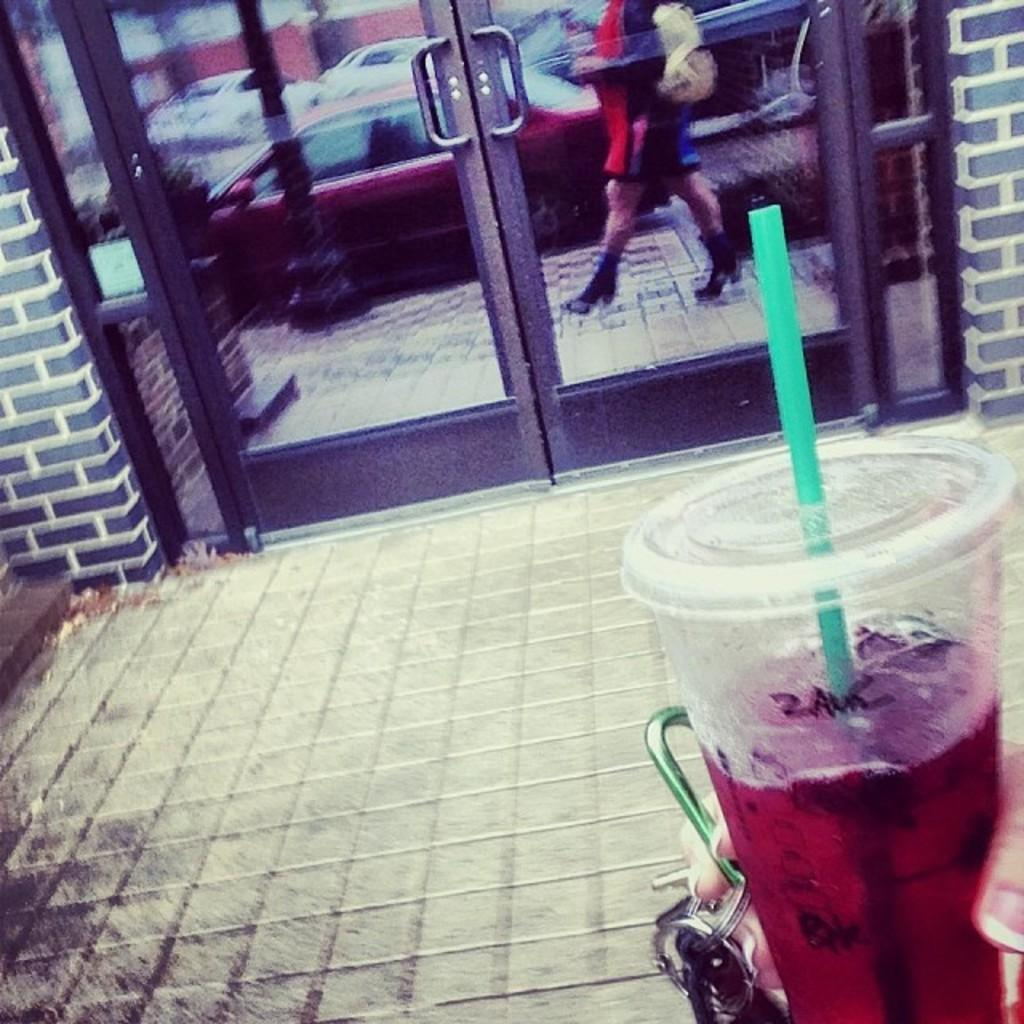What is the person's hand holding in the image? The person's hand is holding a glass in the image. What is inside the glass? The glass contains a liquid. What can be seen in the background of the image? There are doors and a reflection of vehicles in the image. Can you describe the person in the image? There is a person standing in the image. Where is the nest located in the image? There is no nest present in the image. What type of bells can be heard ringing in the image? There are no bells present in the image, and therefore no sounds can be heard. 